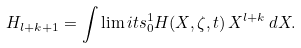Convert formula to latex. <formula><loc_0><loc_0><loc_500><loc_500>H _ { l + k + 1 } = \int \lim i t s _ { 0 } ^ { 1 } H ( X , \zeta , t ) \, X ^ { l + k } \, d X .</formula> 